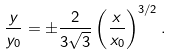<formula> <loc_0><loc_0><loc_500><loc_500>\frac { y } { y _ { 0 } } = \pm \frac { 2 } { 3 \sqrt { 3 } } \left ( \frac { x } { x _ { 0 } } \right ) ^ { 3 / 2 } .</formula> 